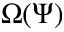<formula> <loc_0><loc_0><loc_500><loc_500>\Omega ( \Psi )</formula> 